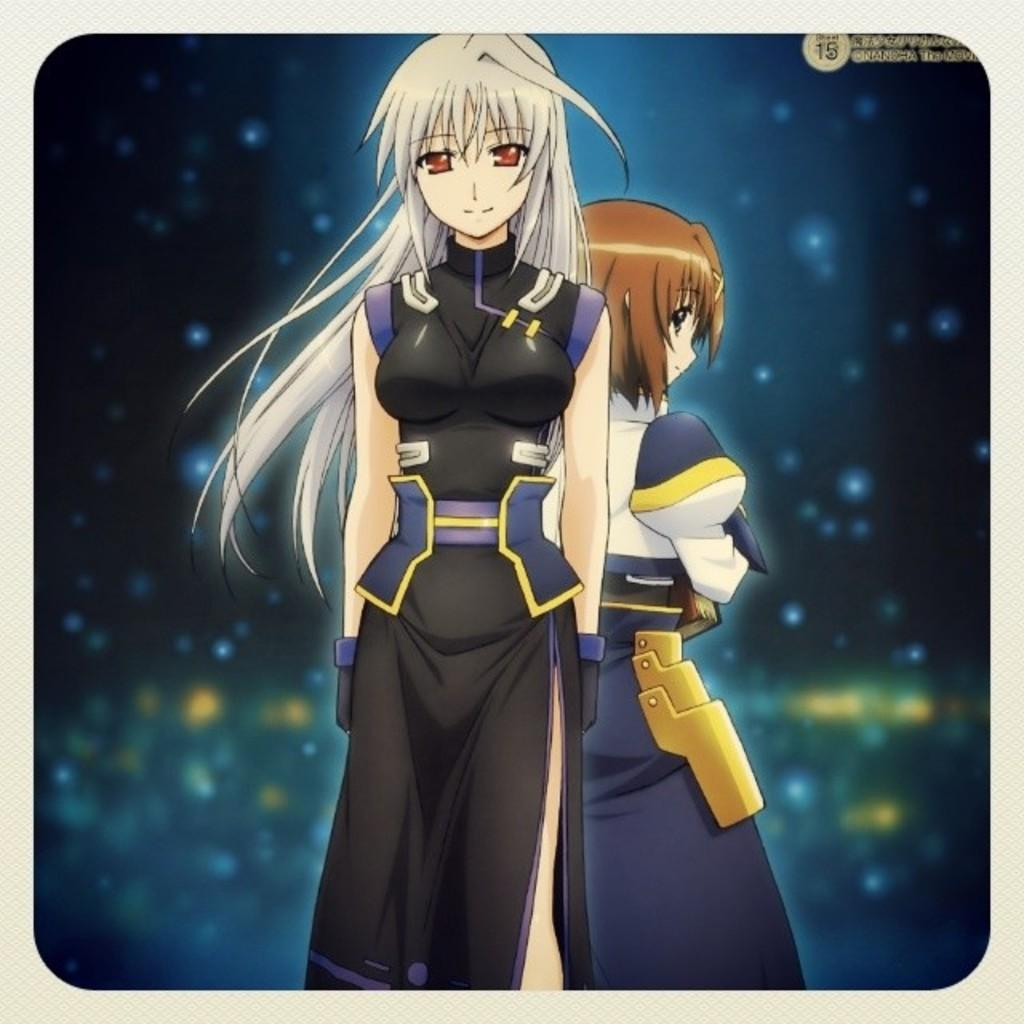What is depicted in the image? There are two cartoons of a woman in the image. How are the cartoons dressed? One of the cartoons is wearing a black dress, and the other is wearing a blue dress. How many books can be seen in the image? There are no books present in the image; it features two cartoons of a woman. What type of fang can be seen in the image? There is no fang present in the image. 